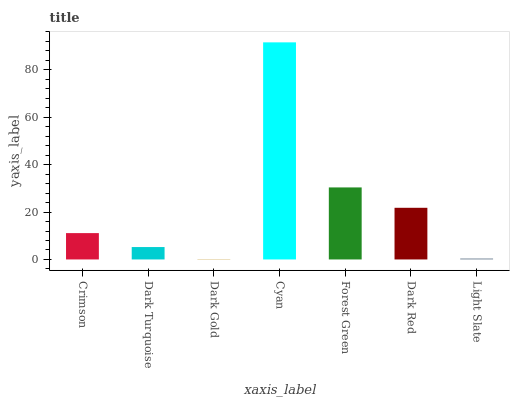Is Dark Gold the minimum?
Answer yes or no. Yes. Is Cyan the maximum?
Answer yes or no. Yes. Is Dark Turquoise the minimum?
Answer yes or no. No. Is Dark Turquoise the maximum?
Answer yes or no. No. Is Crimson greater than Dark Turquoise?
Answer yes or no. Yes. Is Dark Turquoise less than Crimson?
Answer yes or no. Yes. Is Dark Turquoise greater than Crimson?
Answer yes or no. No. Is Crimson less than Dark Turquoise?
Answer yes or no. No. Is Crimson the high median?
Answer yes or no. Yes. Is Crimson the low median?
Answer yes or no. Yes. Is Light Slate the high median?
Answer yes or no. No. Is Forest Green the low median?
Answer yes or no. No. 